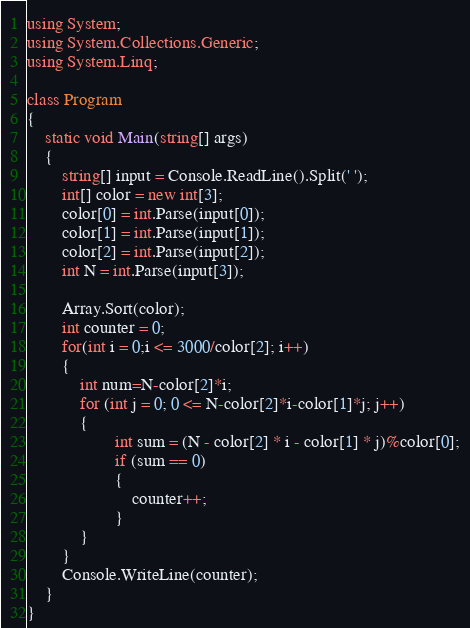Convert code to text. <code><loc_0><loc_0><loc_500><loc_500><_C#_>using System;
using System.Collections.Generic;
using System.Linq;

class Program
{
    static void Main(string[] args)
    {
        string[] input = Console.ReadLine().Split(' ');
        int[] color = new int[3];
        color[0] = int.Parse(input[0]);
        color[1] = int.Parse(input[1]);
        color[2] = int.Parse(input[2]);
        int N = int.Parse(input[3]);

        Array.Sort(color);
        int counter = 0;
        for(int i = 0;i <= 3000/color[2]; i++)
        {
            int num=N-color[2]*i;
            for (int j = 0; 0 <= N-color[2]*i-color[1]*j; j++)
            {
                    int sum = (N - color[2] * i - color[1] * j)%color[0];
                    if (sum == 0)
                    {
                        counter++;
                    }
            }
        }
        Console.WriteLine(counter);
    }
}</code> 